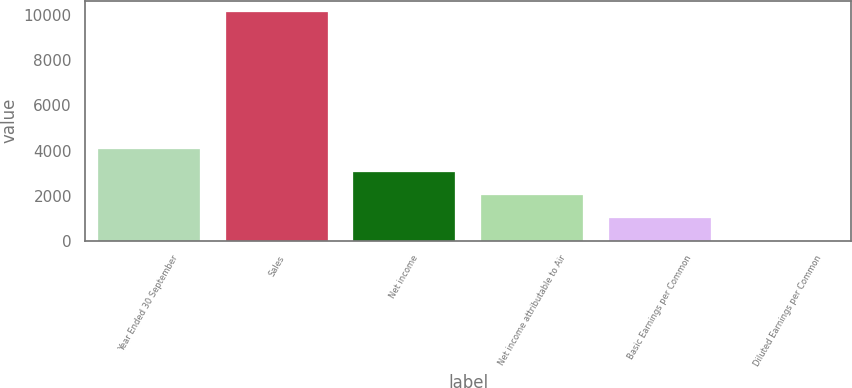Convert chart to OTSL. <chart><loc_0><loc_0><loc_500><loc_500><bar_chart><fcel>Year Ended 30 September<fcel>Sales<fcel>Net income<fcel>Net income attributable to Air<fcel>Basic Earnings per Common<fcel>Diluted Earnings per Common<nl><fcel>4060.83<fcel>10144.2<fcel>3046.93<fcel>2033.03<fcel>1019.13<fcel>5.23<nl></chart> 